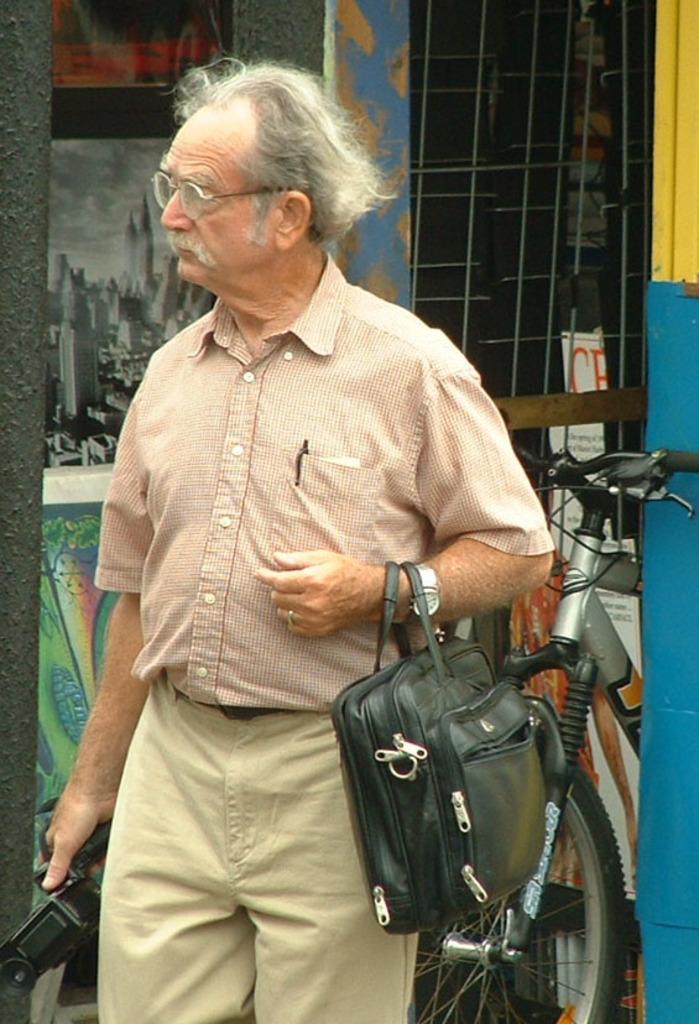Can you describe this image briefly? In the foreground of the picture there is a person holding camera and a bag. In the center of the picture there are poles, bicycle and other objects. In the background there are frames, grills and wall. 